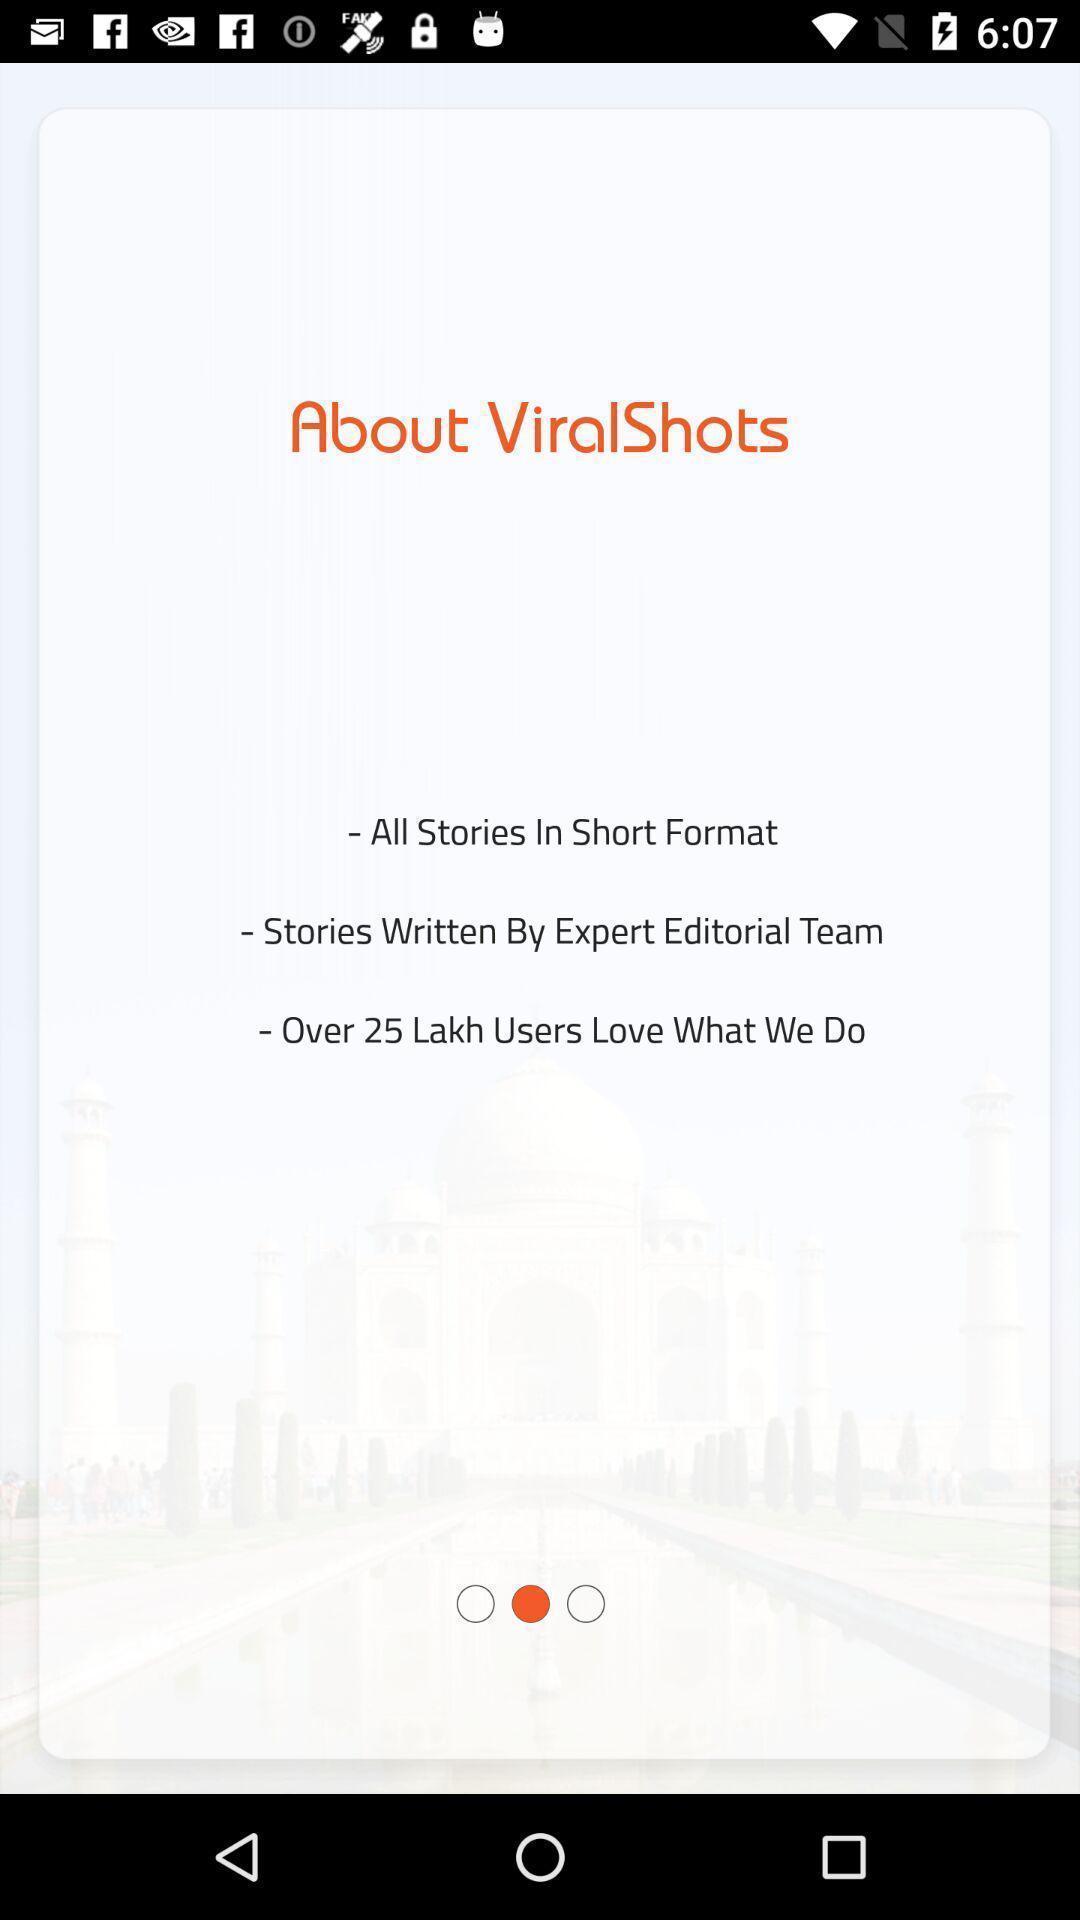Tell me about the visual elements in this screen capture. Welcome page displaying the details. 